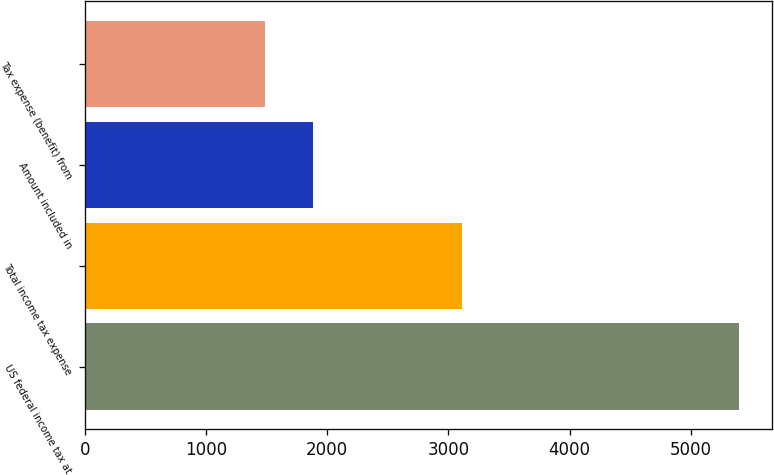Convert chart. <chart><loc_0><loc_0><loc_500><loc_500><bar_chart><fcel>US federal income tax at<fcel>Total income tax expense<fcel>Amount included in<fcel>Tax expense (benefit) from<nl><fcel>5398<fcel>3110<fcel>1879.9<fcel>1489<nl></chart> 